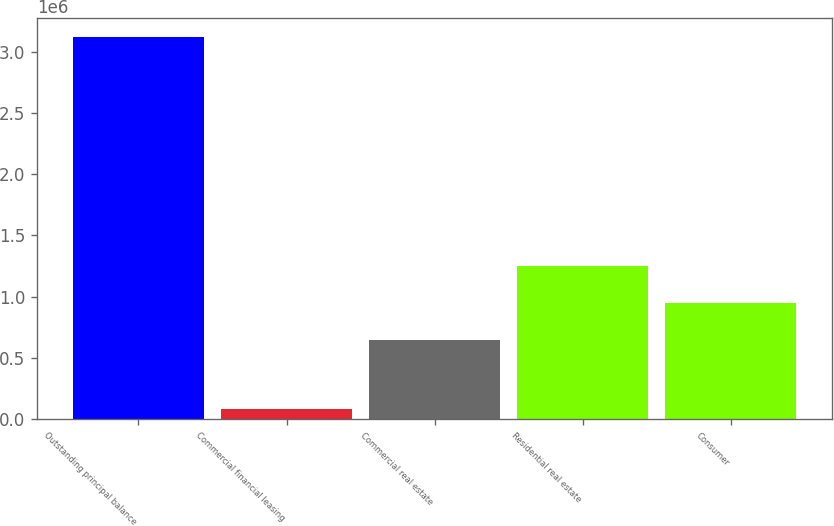<chart> <loc_0><loc_0><loc_500><loc_500><bar_chart><fcel>Outstanding principal balance<fcel>Commercial financial leasing<fcel>Commercial real estate<fcel>Residential real estate<fcel>Consumer<nl><fcel>3.12294e+06<fcel>78847<fcel>644284<fcel>1.2531e+06<fcel>948693<nl></chart> 